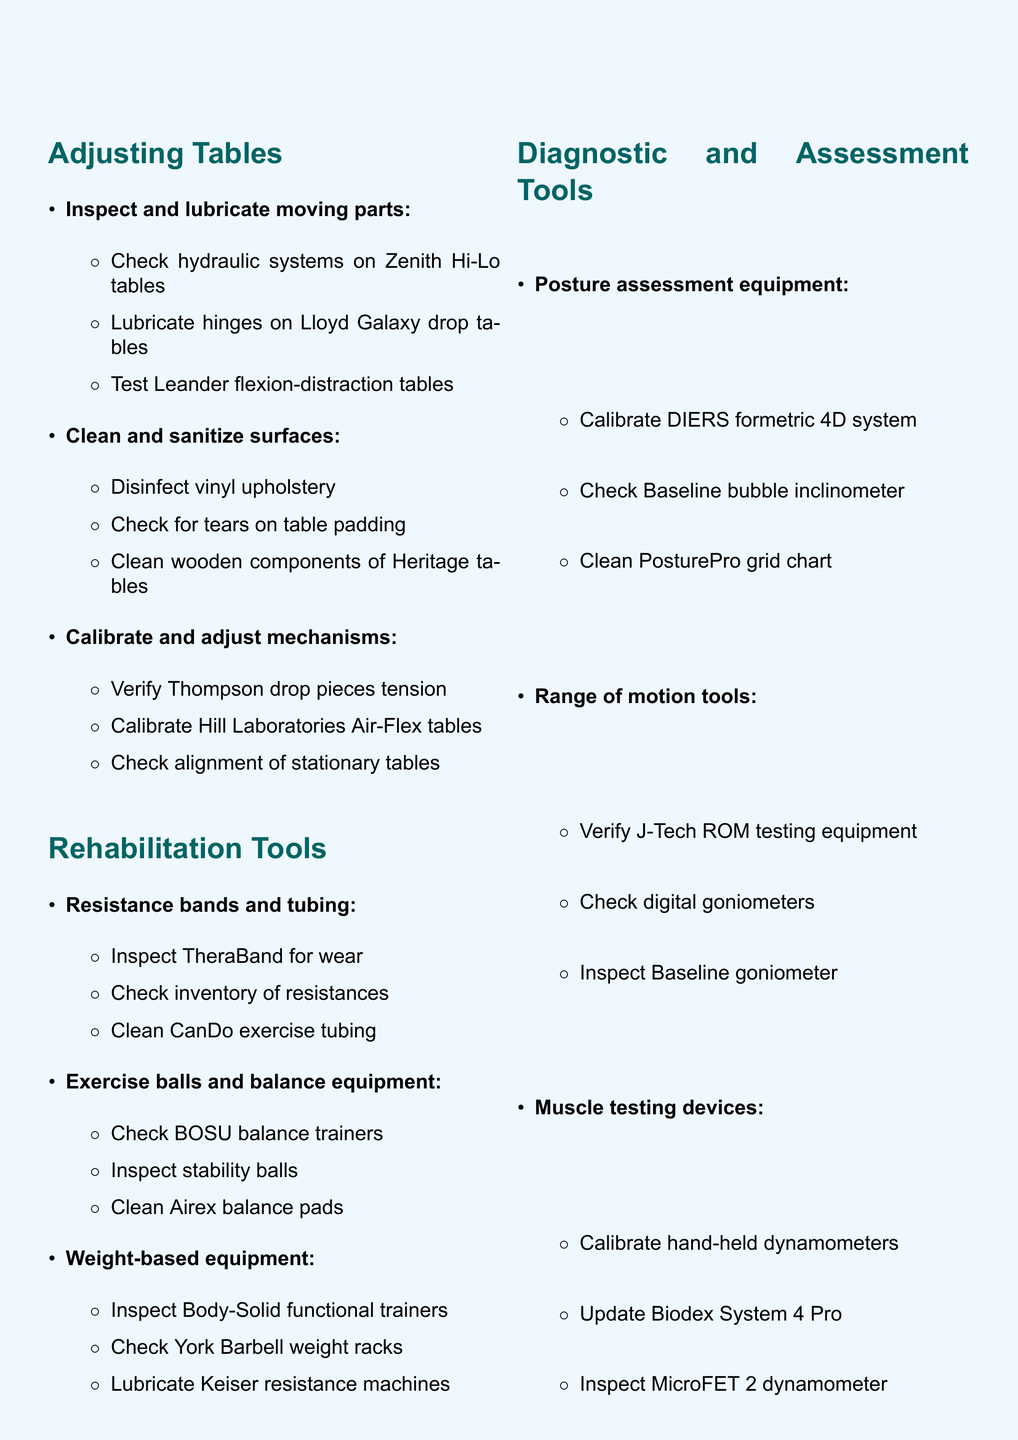what is the title of the agenda? The title is the main heading of the document that summarizes its content.
Answer: Quarterly Equipment Maintenance and Inventory Checklist how many main sections are there in the document? The number of main sections is indicated by the list before the subsections.
Answer: 4 what is the first item under Adjusting Tables for moving parts? The first item listed provides a specific action required for the adjusting tables.
Answer: Check hydraulic systems on Zenith Hi-Lo tables how often should the equipment be maintained according to the document? The frequency of maintenance is indicated in the title of the agenda.
Answer: Quarterly what is the main purpose of the Additional Considerations section? This section summarizes important points that should be emphasized regarding the maintenance of equipment.
Answer: Emphasize importance of proper equipment maintenance for patient safety how many items are there under Rehabilitation Tools for weight-based equipment? This refers to the number of specific tasks that need to be done for that category within the main section.
Answer: 3 which equipment requires air pressure checks? The specific tool that needs air pressure monitoring is detailed in the subsection under rehabilitation tools.
Answer: BOSU balance trainers what should be checked in the Patient Education Materials regarding ergonomic demonstration tools? This question references a specific requirement stated in that subsection.
Answer: Verify all components of office ergonomics kit which equipment is mentioned for posture assessment? This refers to the specific tool used for assessing posture, highlighting its importance in the document.
Answer: DIERS formetric 4D postural analysis system 